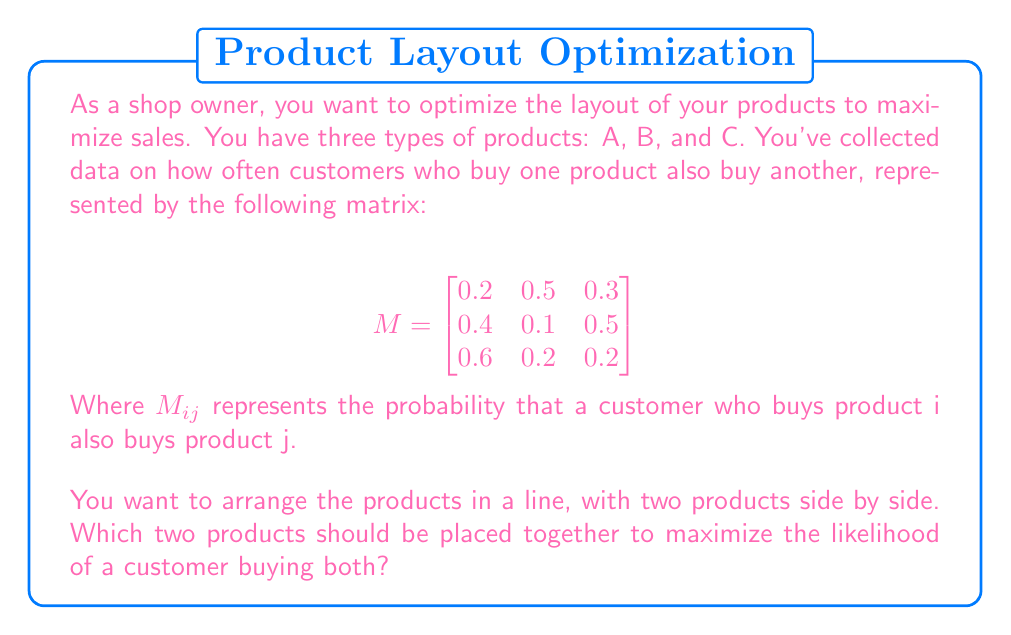Show me your answer to this math problem. To solve this problem, we need to analyze the given matrix and find the highest probability of customers buying two products together. Let's go through the steps:

1) The matrix $M$ represents the probabilities of customers buying products together. For example, $M_{12} = 0.5$ means that 50% of customers who buy product A also buy product B.

2) We need to check the probabilities for each pair of products:
   - A and B: $M_{12} + M_{21} = 0.5 + 0.4 = 0.9$
   - A and C: $M_{13} + M_{31} = 0.3 + 0.6 = 0.9$
   - B and C: $M_{23} + M_{32} = 0.5 + 0.2 = 0.7$

3) We sum the probabilities in both directions because a customer might buy A first and then B, or B first and then A.

4) Comparing the results:
   - A and B: 0.9
   - A and C: 0.9
   - B and C: 0.7

5) We can see that the highest probability is 0.9, which occurs for both A and B, and A and C.

6) In this case, we have a tie between two options. Either choice would be equally optimal based on the given data.
Answer: Products A and B, or A and C (0.9 probability for either pair) 